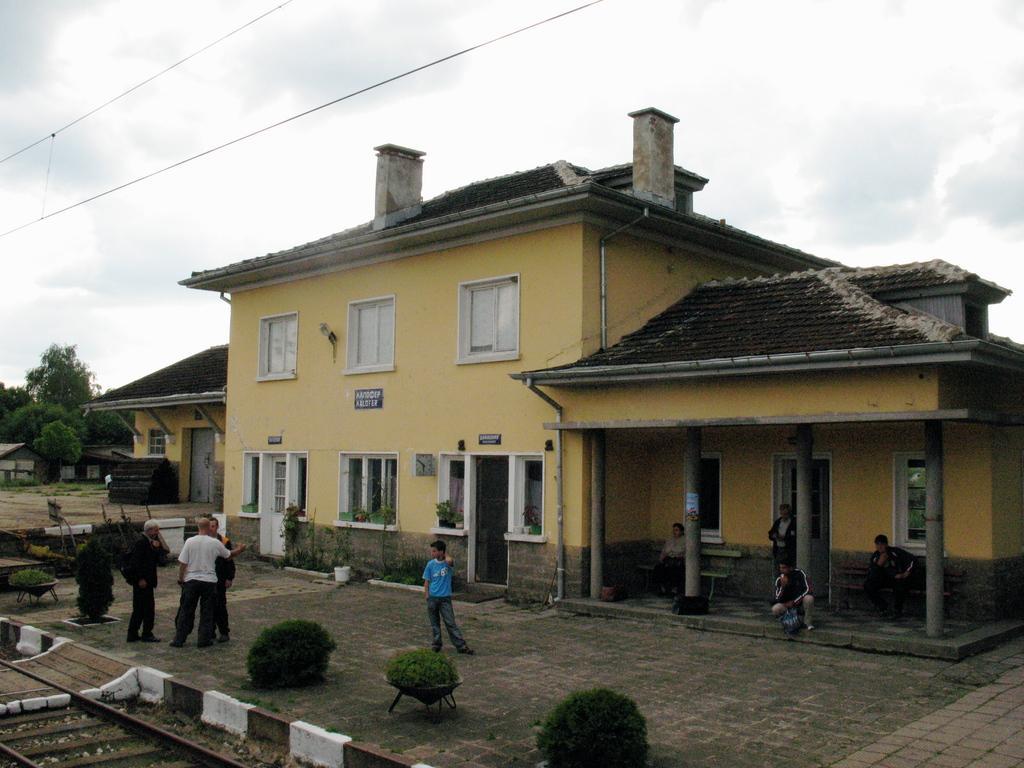Can you describe this image briefly? In the center of the image there are buildings. At the bottom we can see people standing and some of them are sitting. There are bushes. In the background there are trees, wires and sky. At the bottom there is a track. 